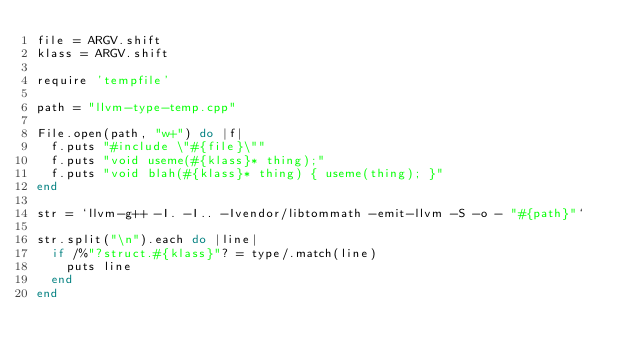<code> <loc_0><loc_0><loc_500><loc_500><_Ruby_>file = ARGV.shift
klass = ARGV.shift

require 'tempfile'

path = "llvm-type-temp.cpp"

File.open(path, "w+") do |f|
  f.puts "#include \"#{file}\""
  f.puts "void useme(#{klass}* thing);"
  f.puts "void blah(#{klass}* thing) { useme(thing); }"
end

str = `llvm-g++ -I. -I.. -Ivendor/libtommath -emit-llvm -S -o - "#{path}"`

str.split("\n").each do |line|
  if /%"?struct.#{klass}"? = type/.match(line)
    puts line
  end
end
</code> 